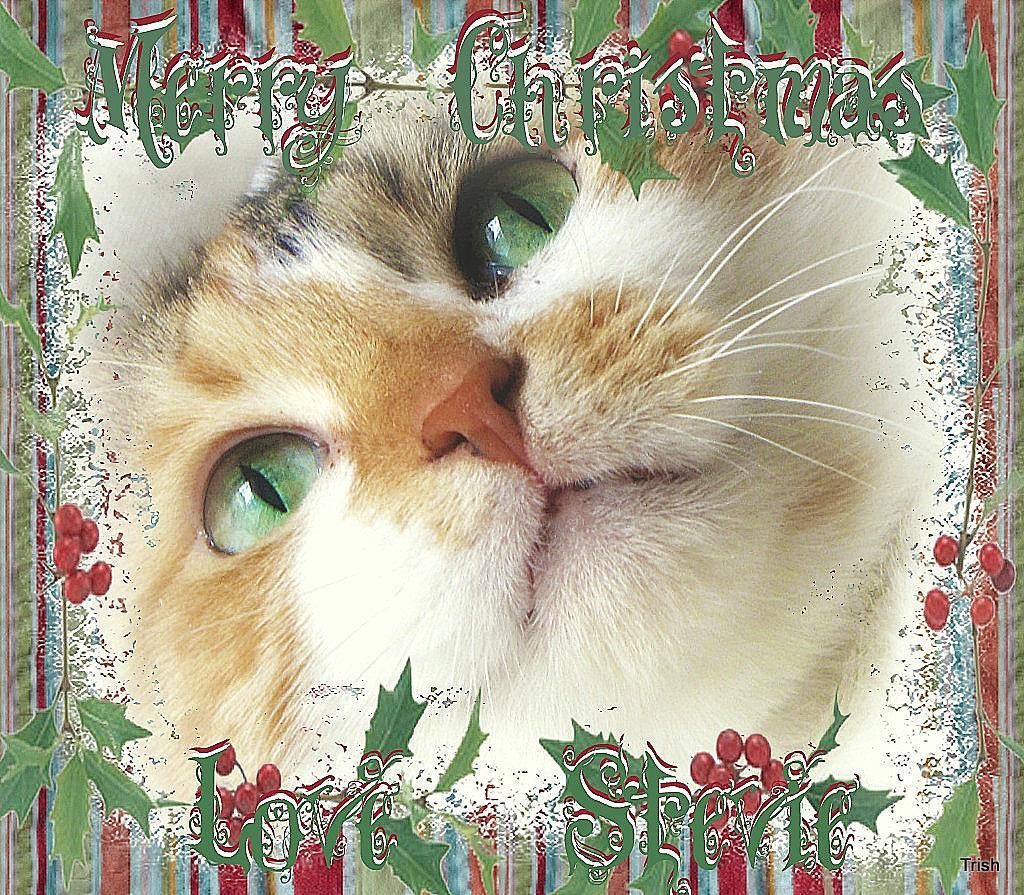In one or two sentences, can you explain what this image depicts? In this picture we can see face of a cat in the middle, we can also see some text. 